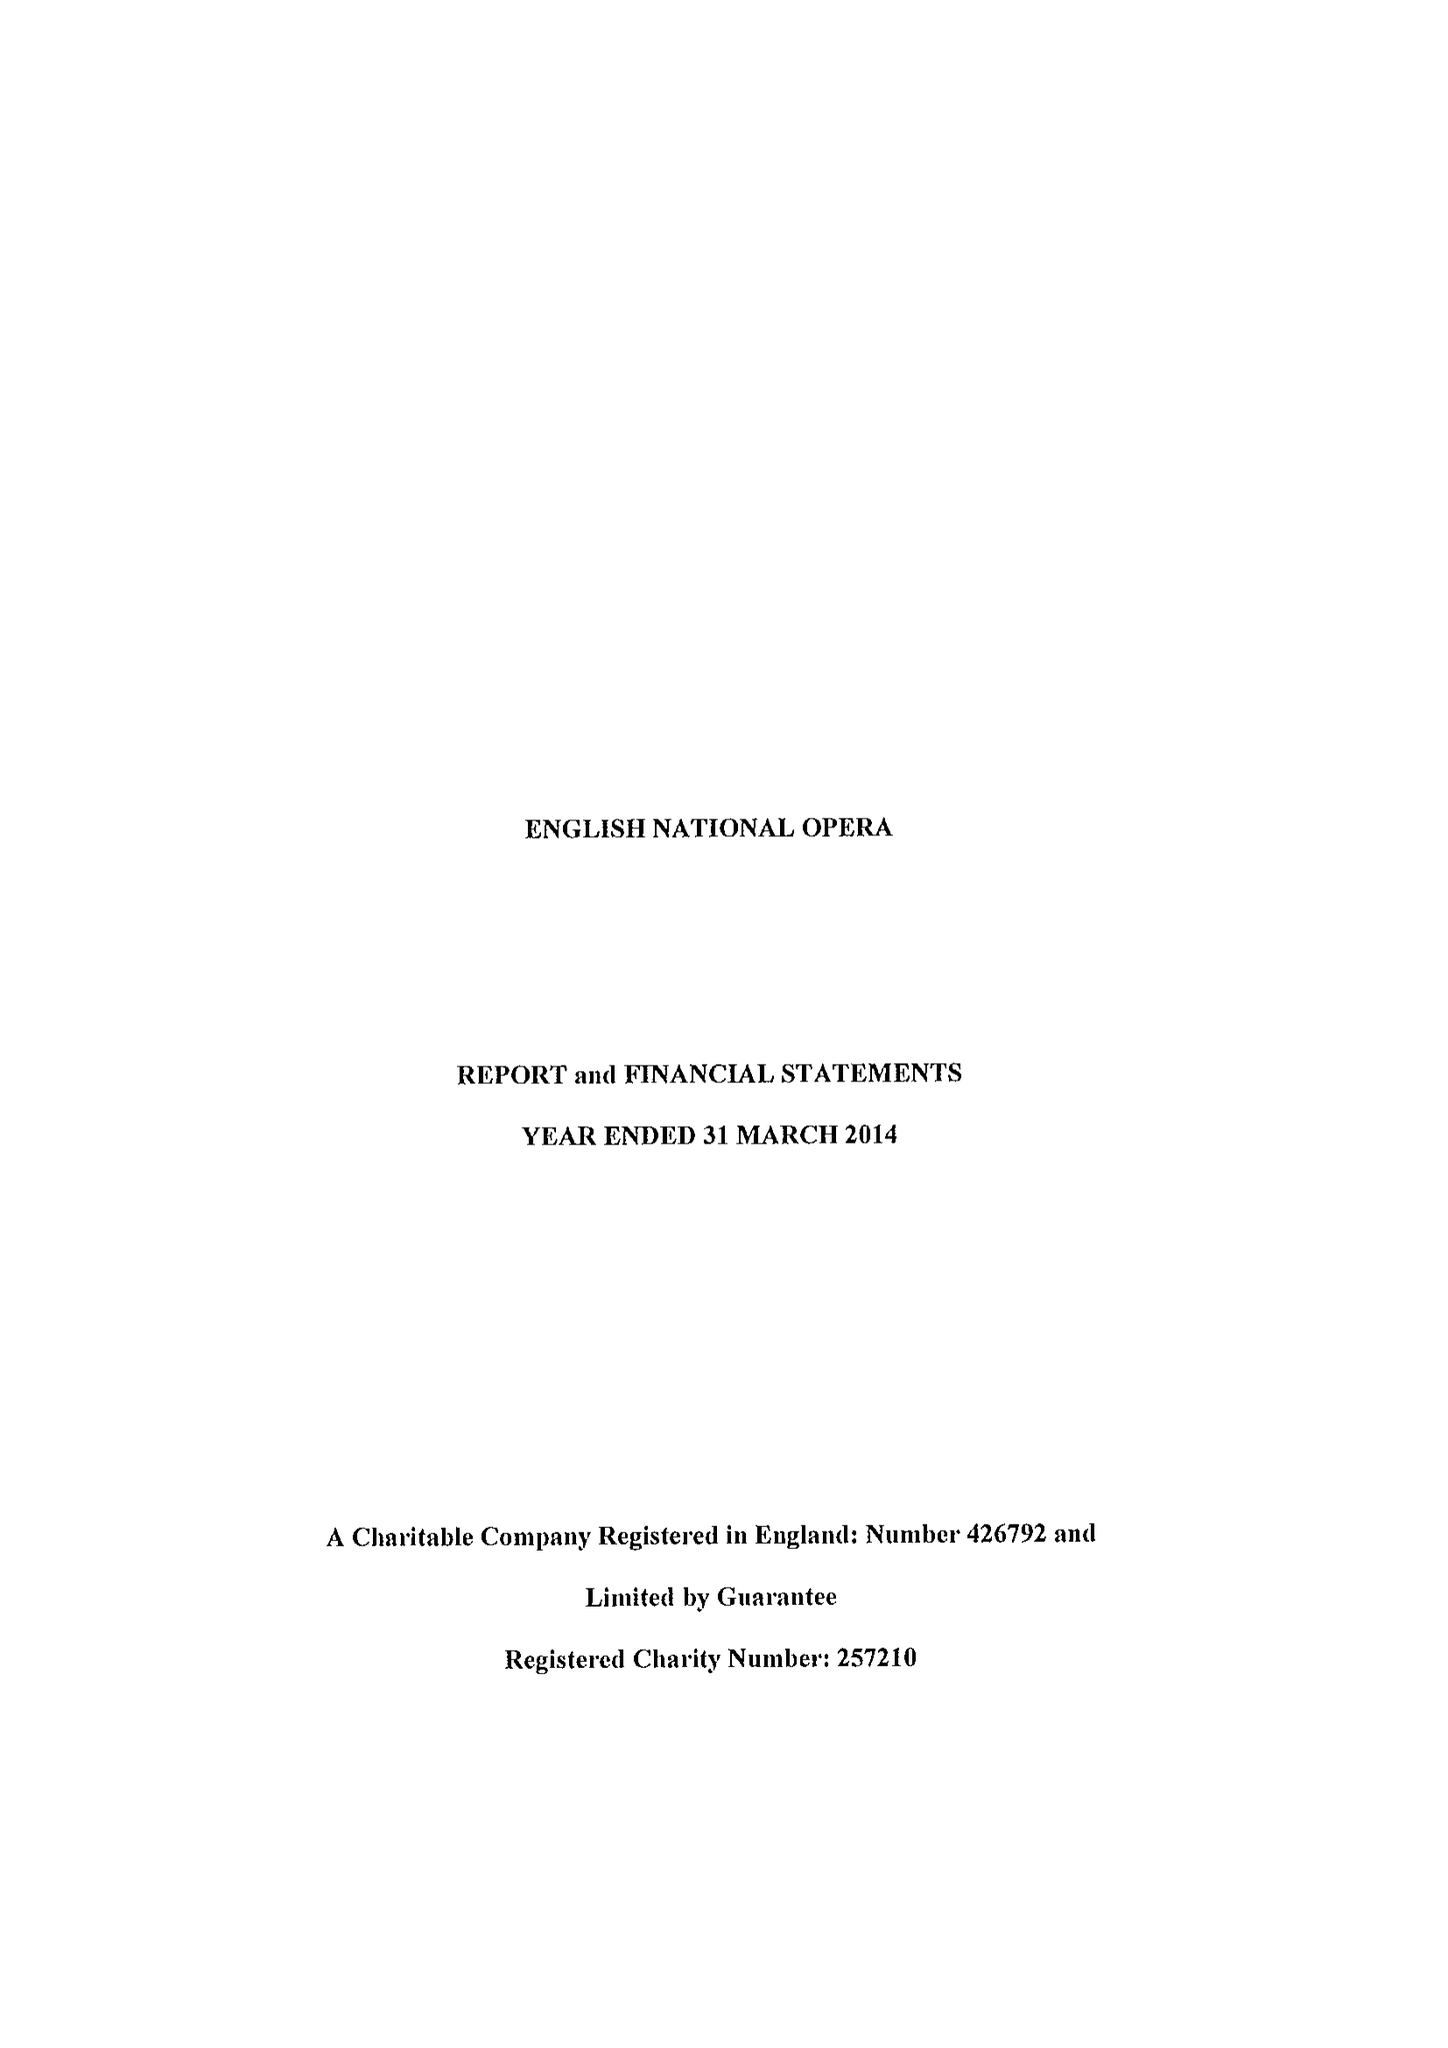What is the value for the charity_number?
Answer the question using a single word or phrase. 257210 